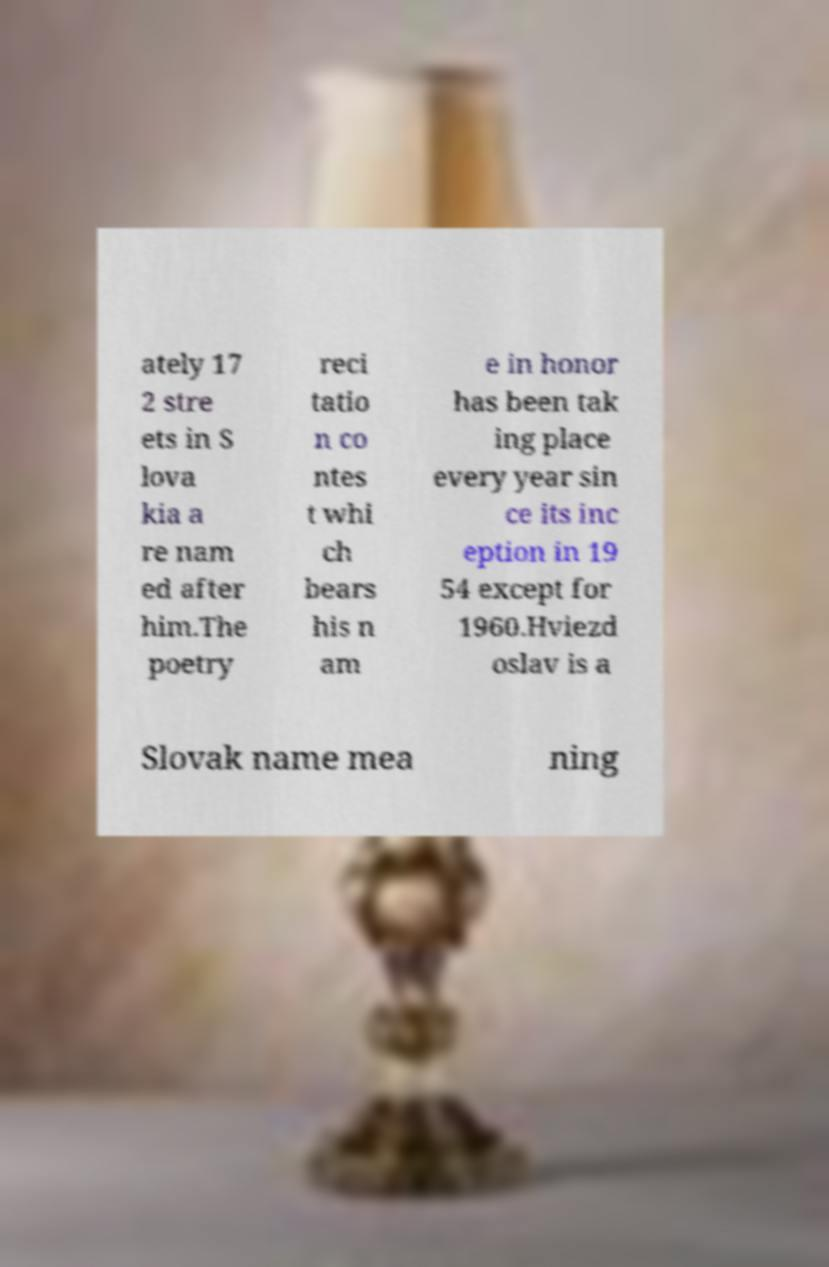Please read and relay the text visible in this image. What does it say? ately 17 2 stre ets in S lova kia a re nam ed after him.The poetry reci tatio n co ntes t whi ch bears his n am e in honor has been tak ing place every year sin ce its inc eption in 19 54 except for 1960.Hviezd oslav is a Slovak name mea ning 